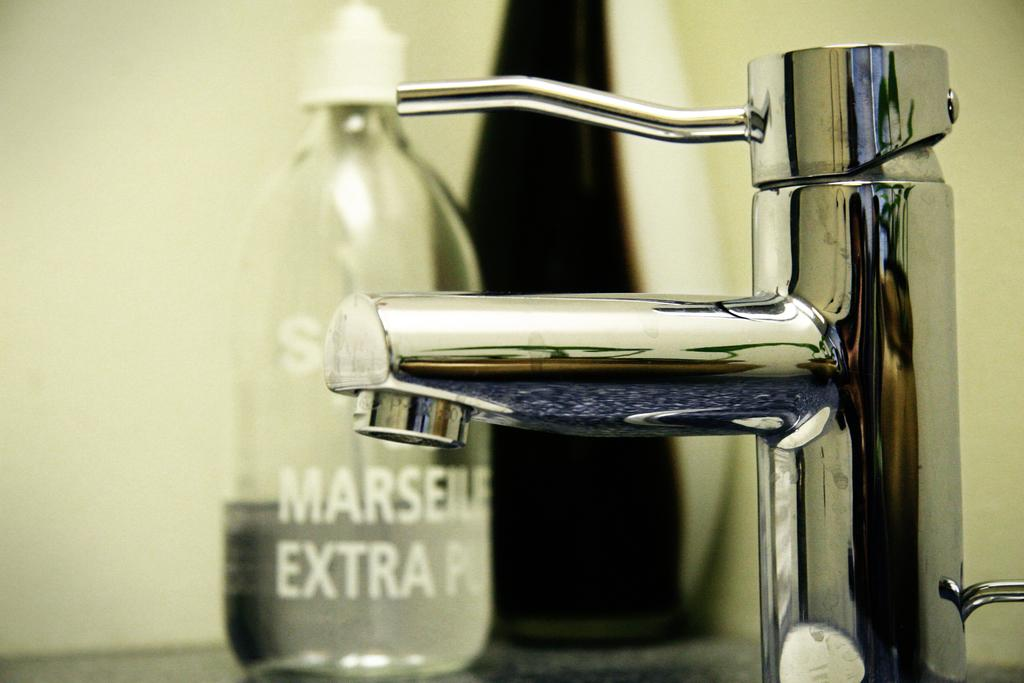Provide a one-sentence caption for the provided image. A bottle of soap with the word EXTRA sits behind a sink faucet. 